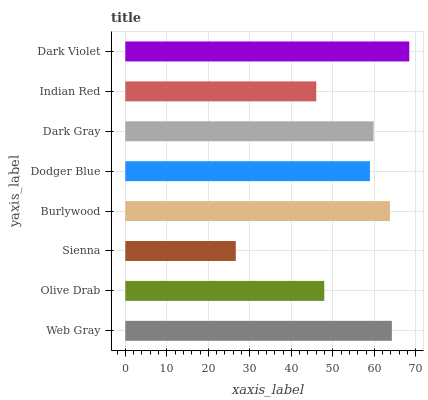Is Sienna the minimum?
Answer yes or no. Yes. Is Dark Violet the maximum?
Answer yes or no. Yes. Is Olive Drab the minimum?
Answer yes or no. No. Is Olive Drab the maximum?
Answer yes or no. No. Is Web Gray greater than Olive Drab?
Answer yes or no. Yes. Is Olive Drab less than Web Gray?
Answer yes or no. Yes. Is Olive Drab greater than Web Gray?
Answer yes or no. No. Is Web Gray less than Olive Drab?
Answer yes or no. No. Is Dark Gray the high median?
Answer yes or no. Yes. Is Dodger Blue the low median?
Answer yes or no. Yes. Is Olive Drab the high median?
Answer yes or no. No. Is Olive Drab the low median?
Answer yes or no. No. 